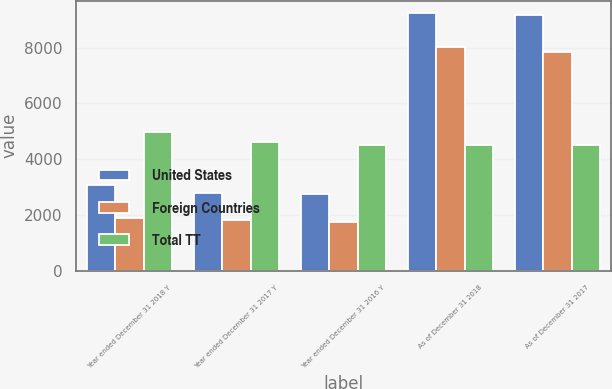Convert chart to OTSL. <chart><loc_0><loc_0><loc_500><loc_500><stacked_bar_chart><ecel><fcel>Year ended December 31 2018 Y<fcel>Year ended December 31 2017 Y<fcel>Year ended December 31 2016 Y<fcel>As of December 31 2018<fcel>As of December 31 2017<nl><fcel>United States<fcel>3087<fcel>2807<fcel>2757<fcel>9226<fcel>9152<nl><fcel>Foreign Countries<fcel>1892<fcel>1831<fcel>1755<fcel>8005<fcel>7833<nl><fcel>Total TT<fcel>4979<fcel>4638<fcel>4512<fcel>4512<fcel>4512<nl></chart> 